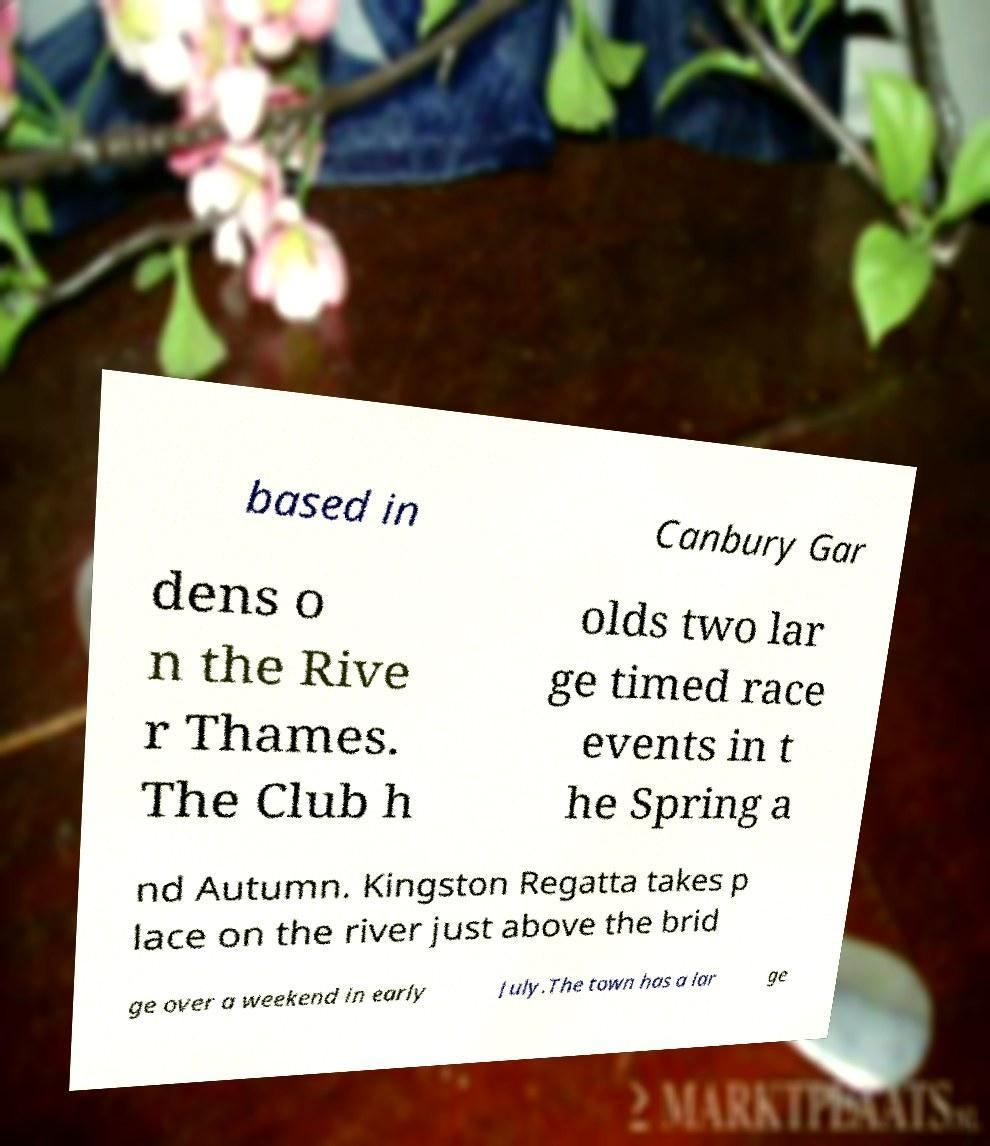Please read and relay the text visible in this image. What does it say? based in Canbury Gar dens o n the Rive r Thames. The Club h olds two lar ge timed race events in t he Spring a nd Autumn. Kingston Regatta takes p lace on the river just above the brid ge over a weekend in early July.The town has a lar ge 